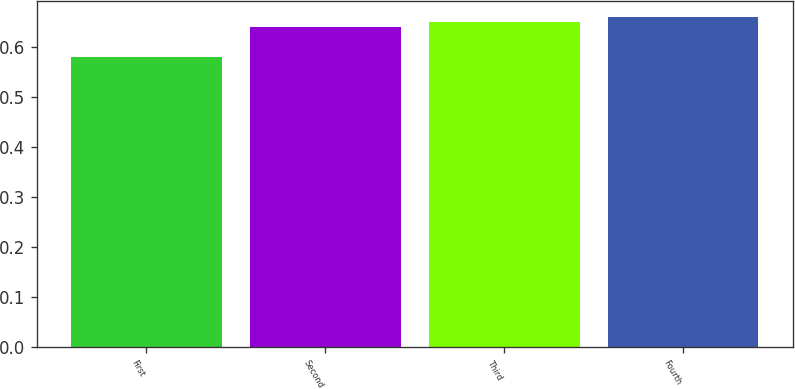Convert chart to OTSL. <chart><loc_0><loc_0><loc_500><loc_500><bar_chart><fcel>First<fcel>Second<fcel>Third<fcel>Fourth<nl><fcel>0.58<fcel>0.64<fcel>0.65<fcel>0.66<nl></chart> 